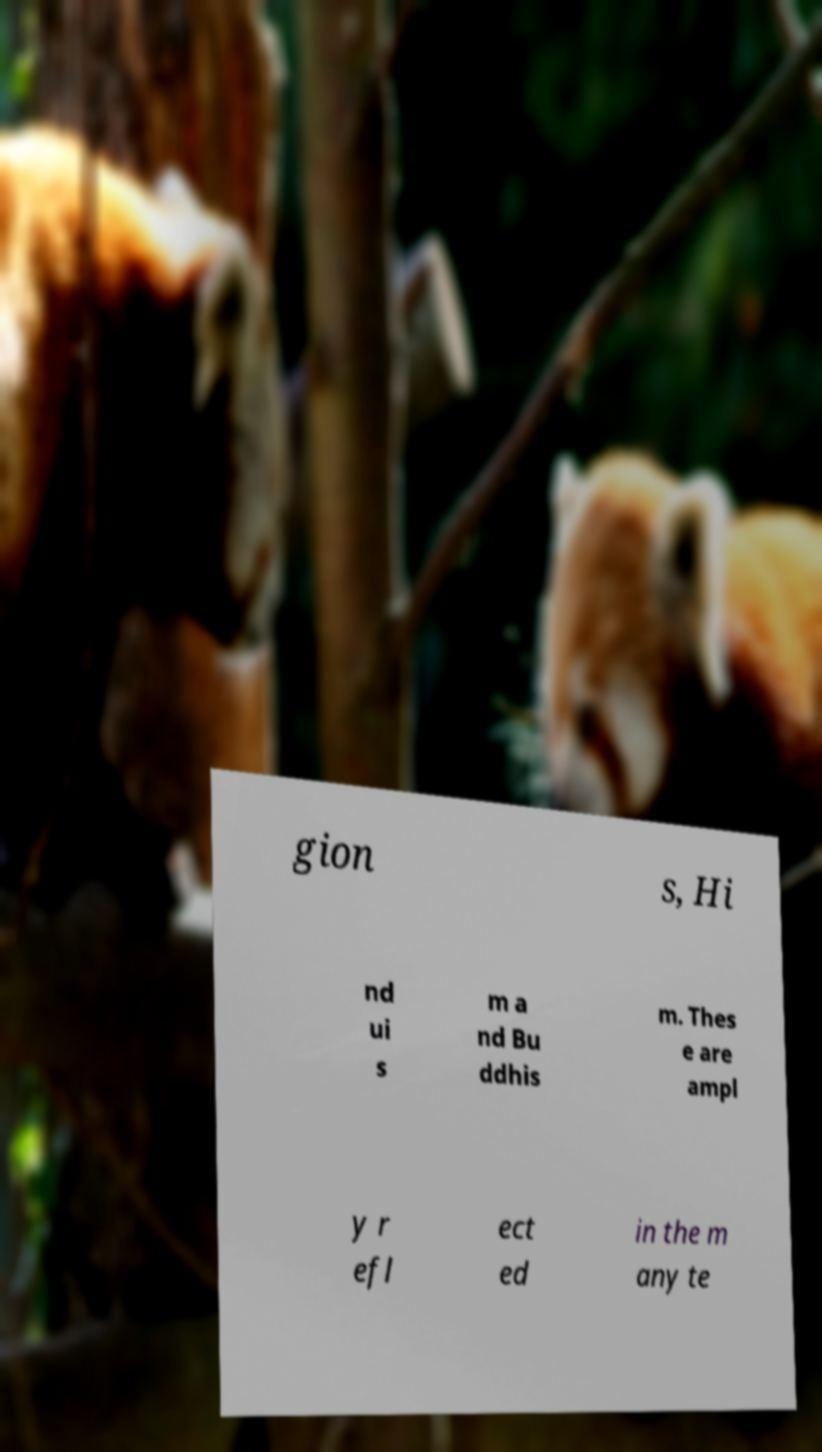For documentation purposes, I need the text within this image transcribed. Could you provide that? gion s, Hi nd ui s m a nd Bu ddhis m. Thes e are ampl y r efl ect ed in the m any te 